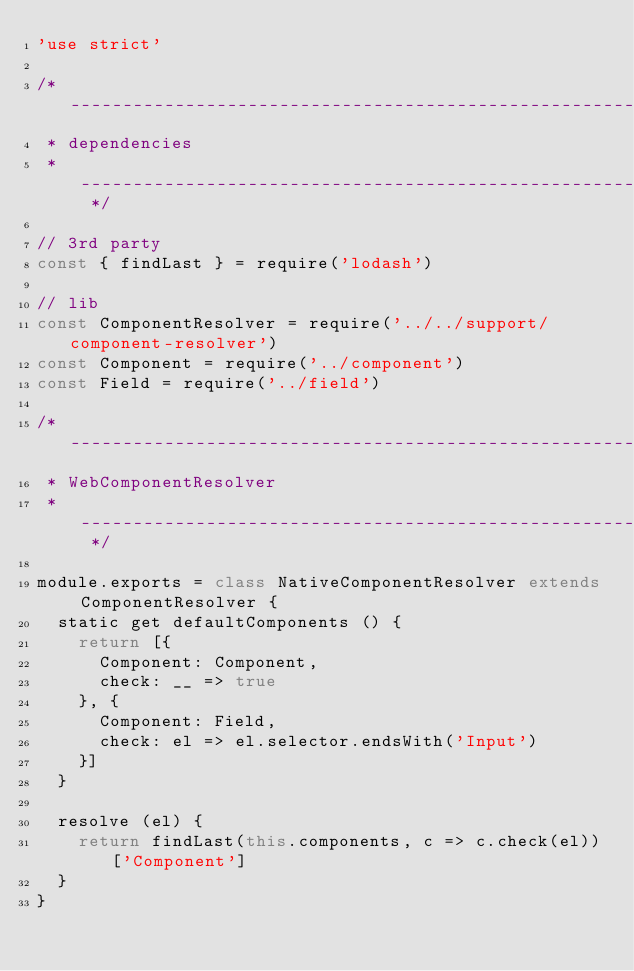Convert code to text. <code><loc_0><loc_0><loc_500><loc_500><_JavaScript_>'use strict'

/* -----------------------------------------------------------------------------
 * dependencies
 * -------------------------------------------------------------------------- */

// 3rd party
const { findLast } = require('lodash')

// lib
const ComponentResolver = require('../../support/component-resolver')
const Component = require('../component')
const Field = require('../field')

/* -----------------------------------------------------------------------------
 * WebComponentResolver
 * -------------------------------------------------------------------------- */

module.exports = class NativeComponentResolver extends ComponentResolver {
  static get defaultComponents () {
    return [{
      Component: Component,
      check: __ => true
    }, {
      Component: Field,
      check: el => el.selector.endsWith('Input')
    }]
  }

  resolve (el) {
    return findLast(this.components, c => c.check(el))['Component']
  }
}
</code> 